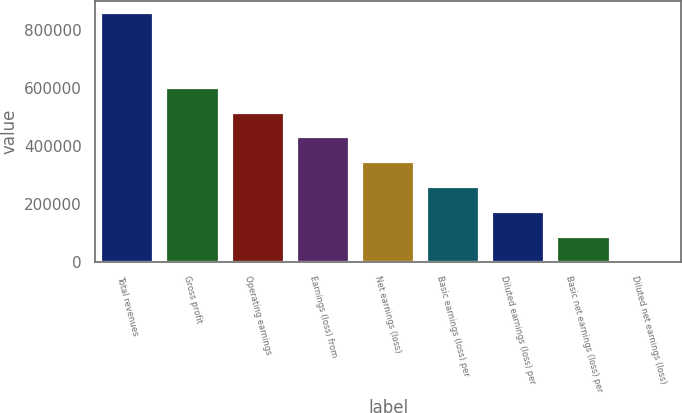Convert chart. <chart><loc_0><loc_0><loc_500><loc_500><bar_chart><fcel>Total revenues<fcel>Gross profit<fcel>Operating earnings<fcel>Earnings (loss) from<fcel>Net earnings (loss)<fcel>Basic earnings (loss) per<fcel>Diluted earnings (loss) per<fcel>Basic net earnings (loss) per<fcel>Diluted net earnings (loss)<nl><fcel>857285<fcel>600100<fcel>514371<fcel>428643<fcel>342914<fcel>257186<fcel>171458<fcel>85729.1<fcel>0.65<nl></chart> 